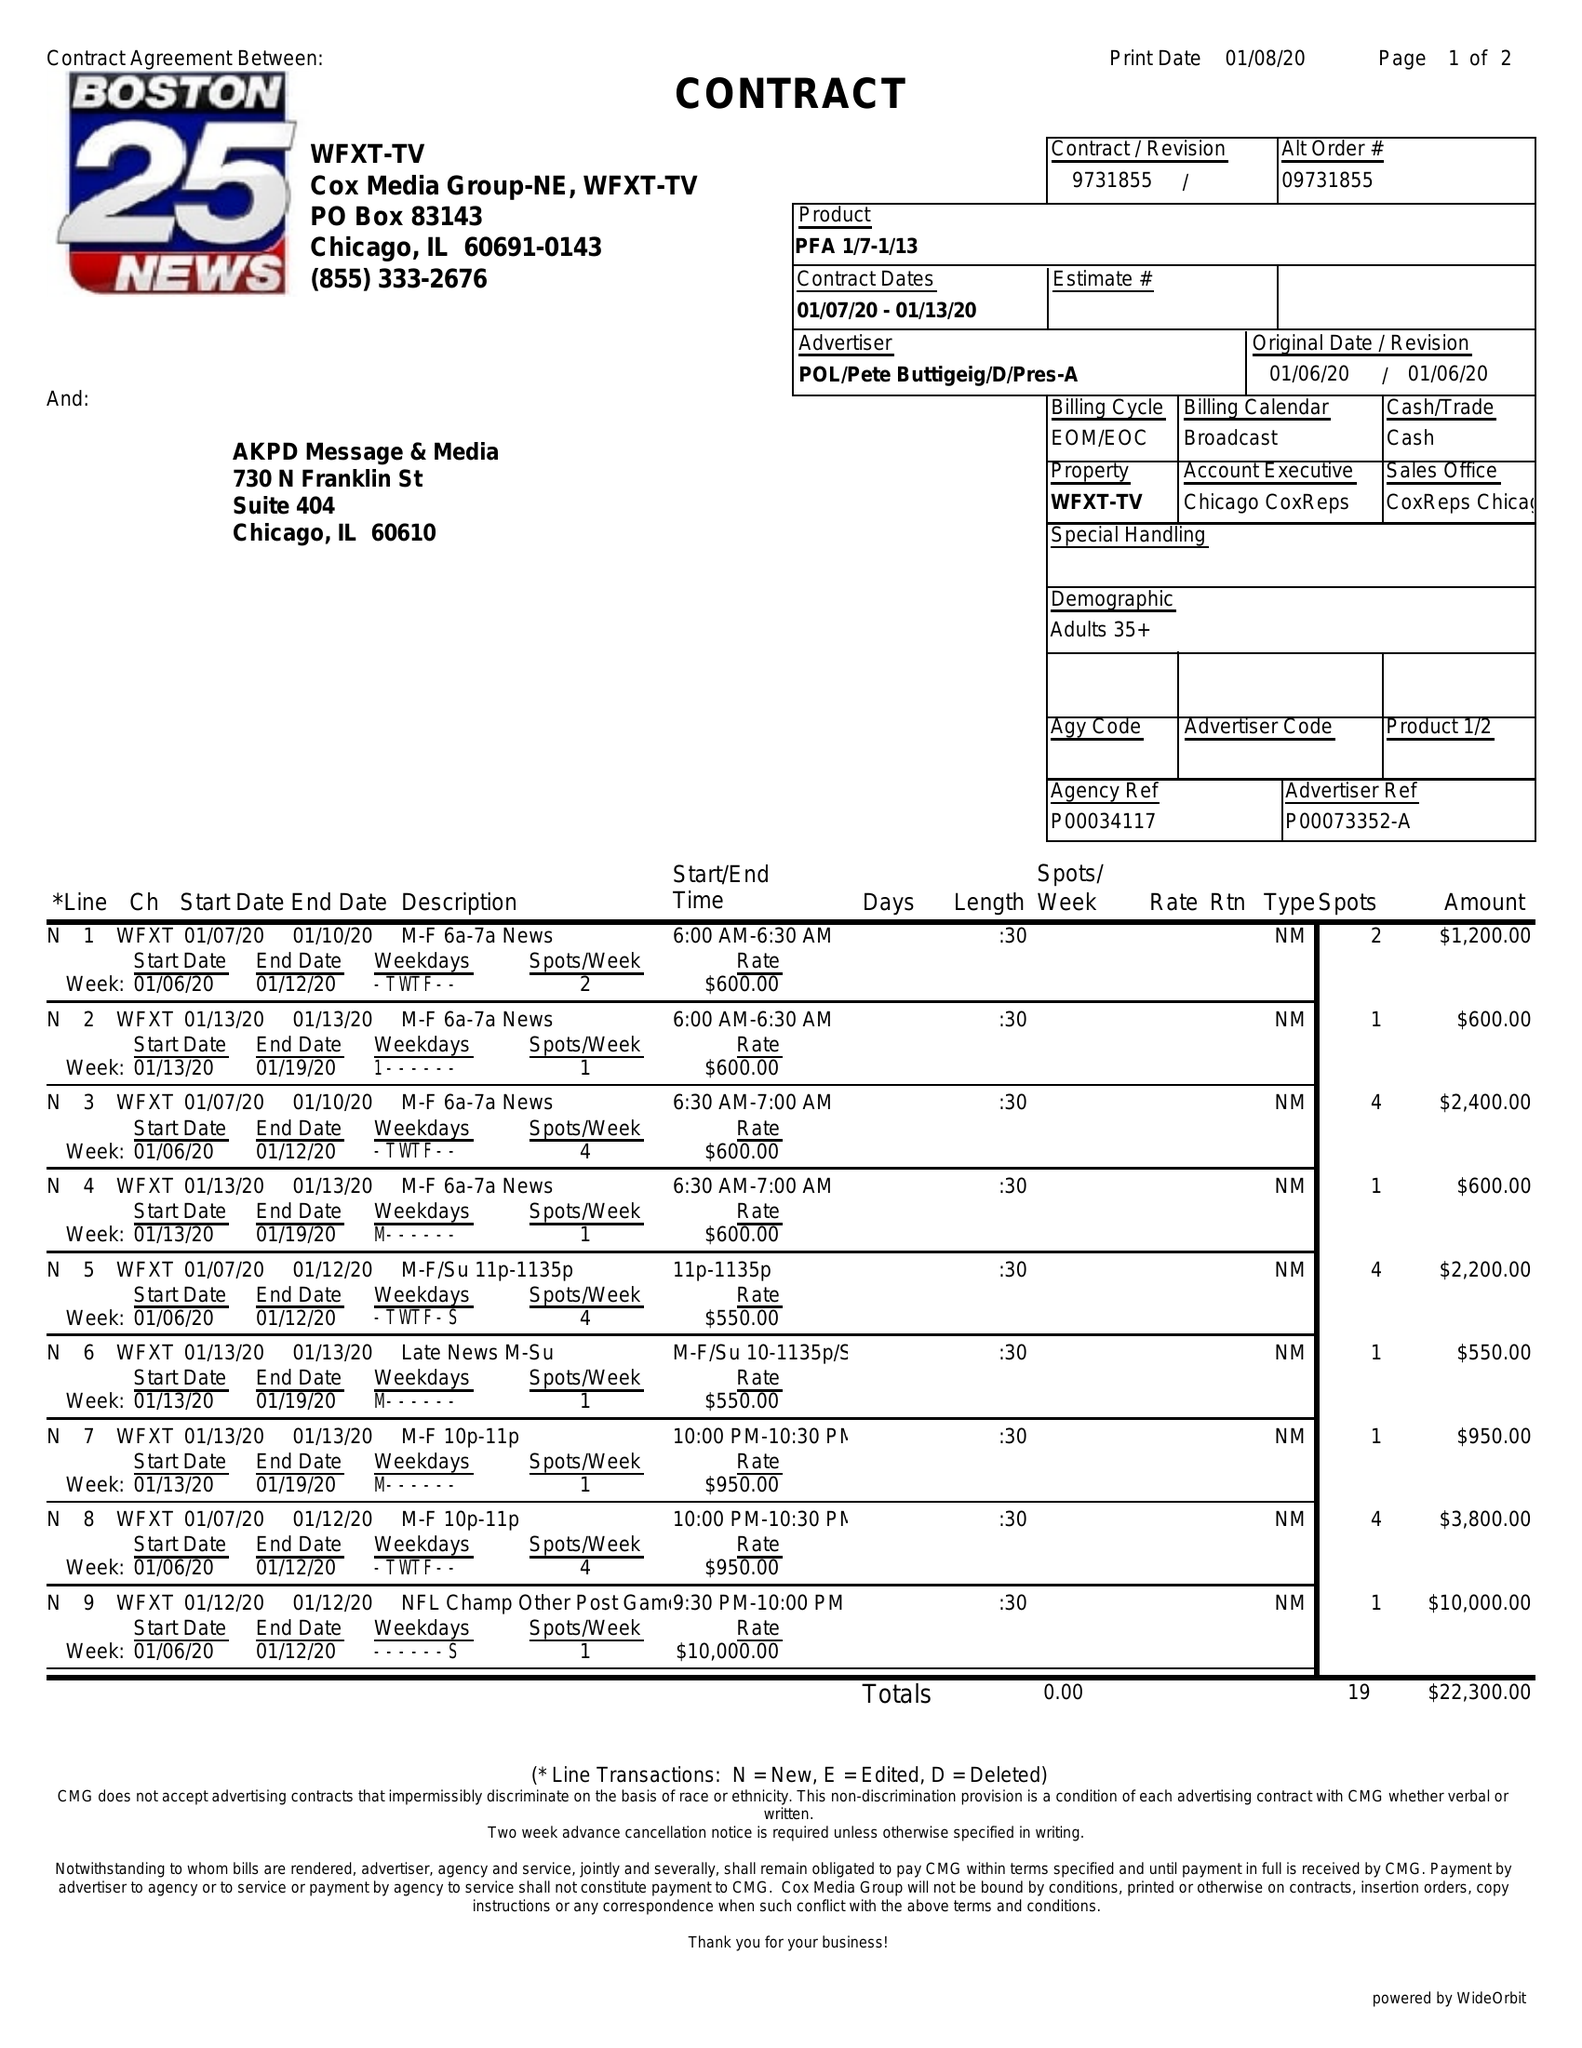What is the value for the contract_num?
Answer the question using a single word or phrase. 9731855 